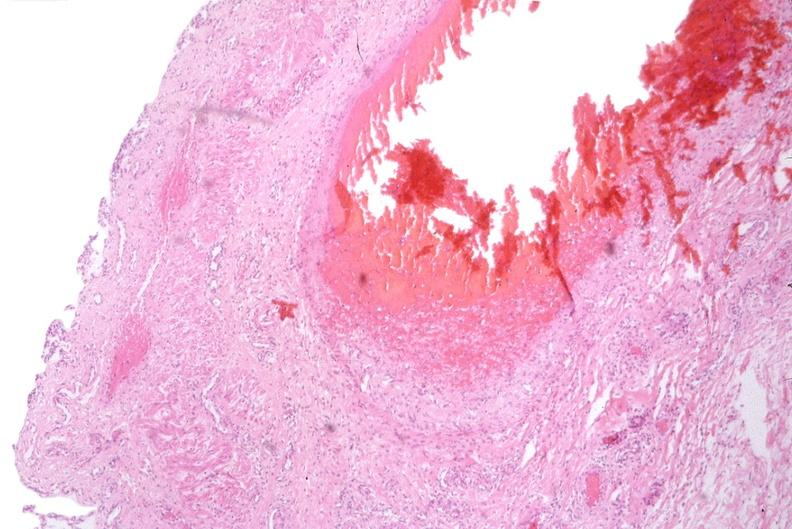does this image show esophogus, varices due to portal hypertension from cirrhosis, hcv?
Answer the question using a single word or phrase. Yes 